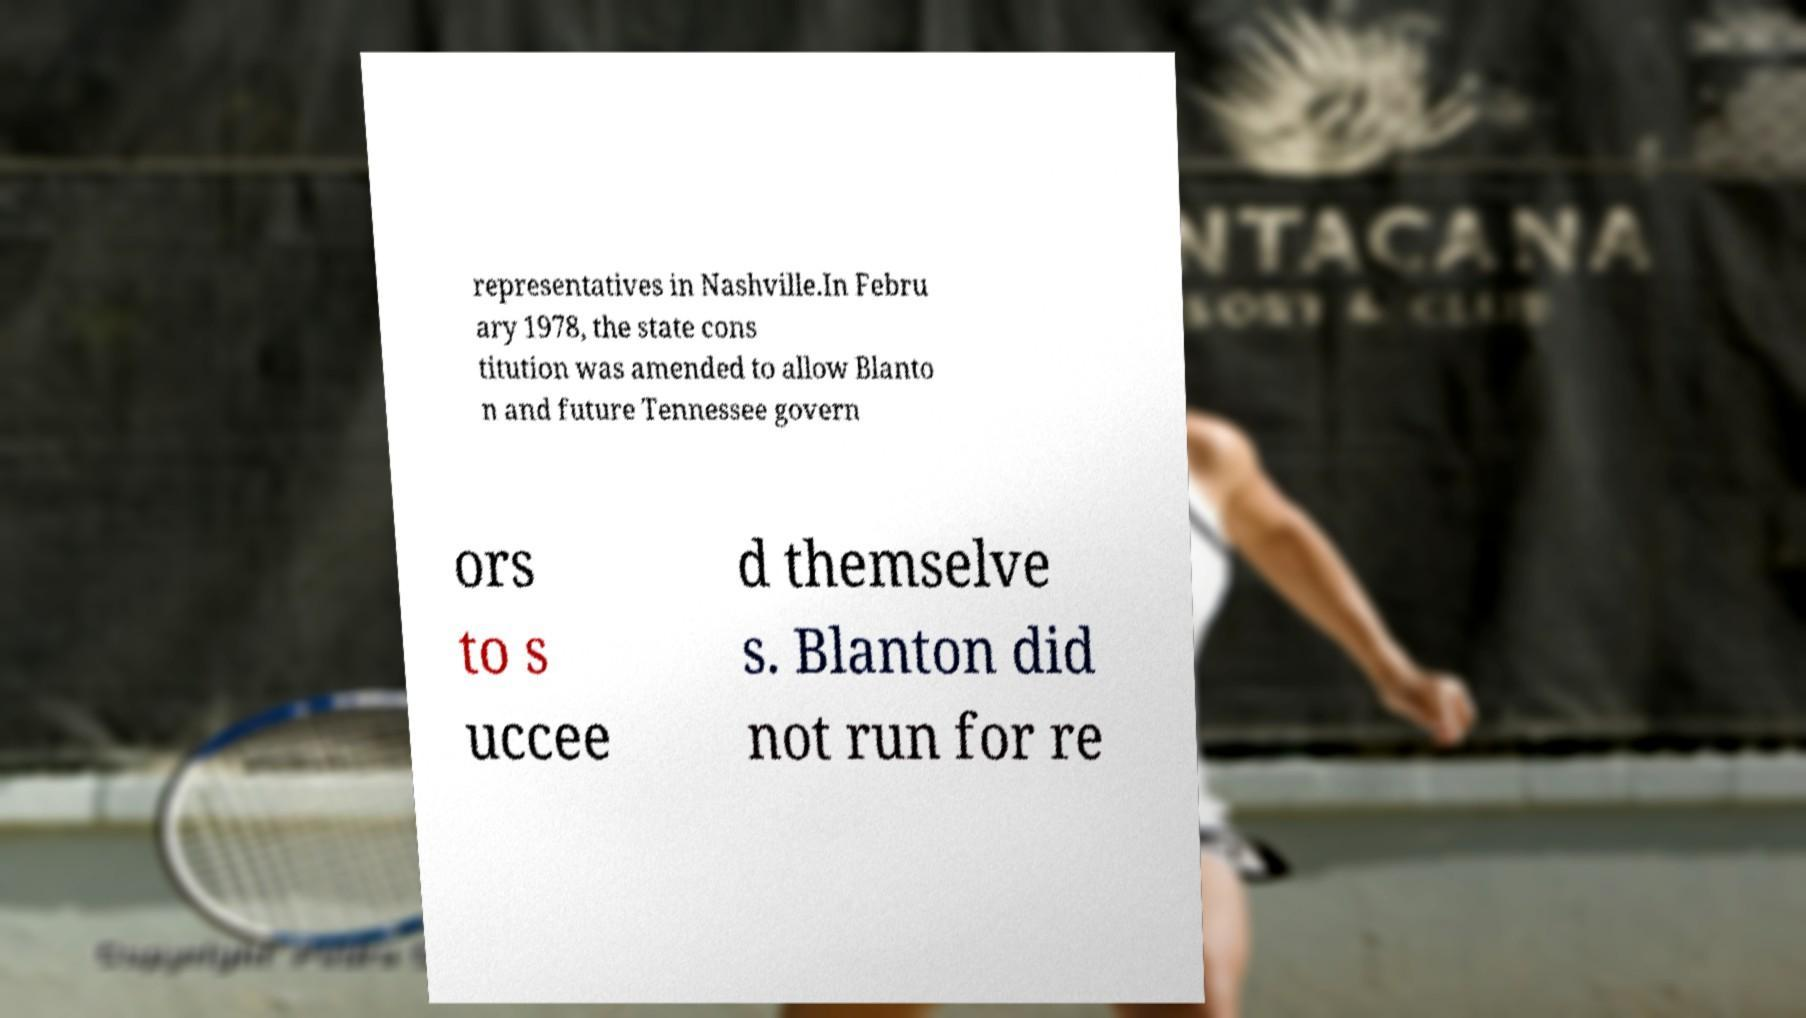Can you accurately transcribe the text from the provided image for me? representatives in Nashville.In Febru ary 1978, the state cons titution was amended to allow Blanto n and future Tennessee govern ors to s uccee d themselve s. Blanton did not run for re 